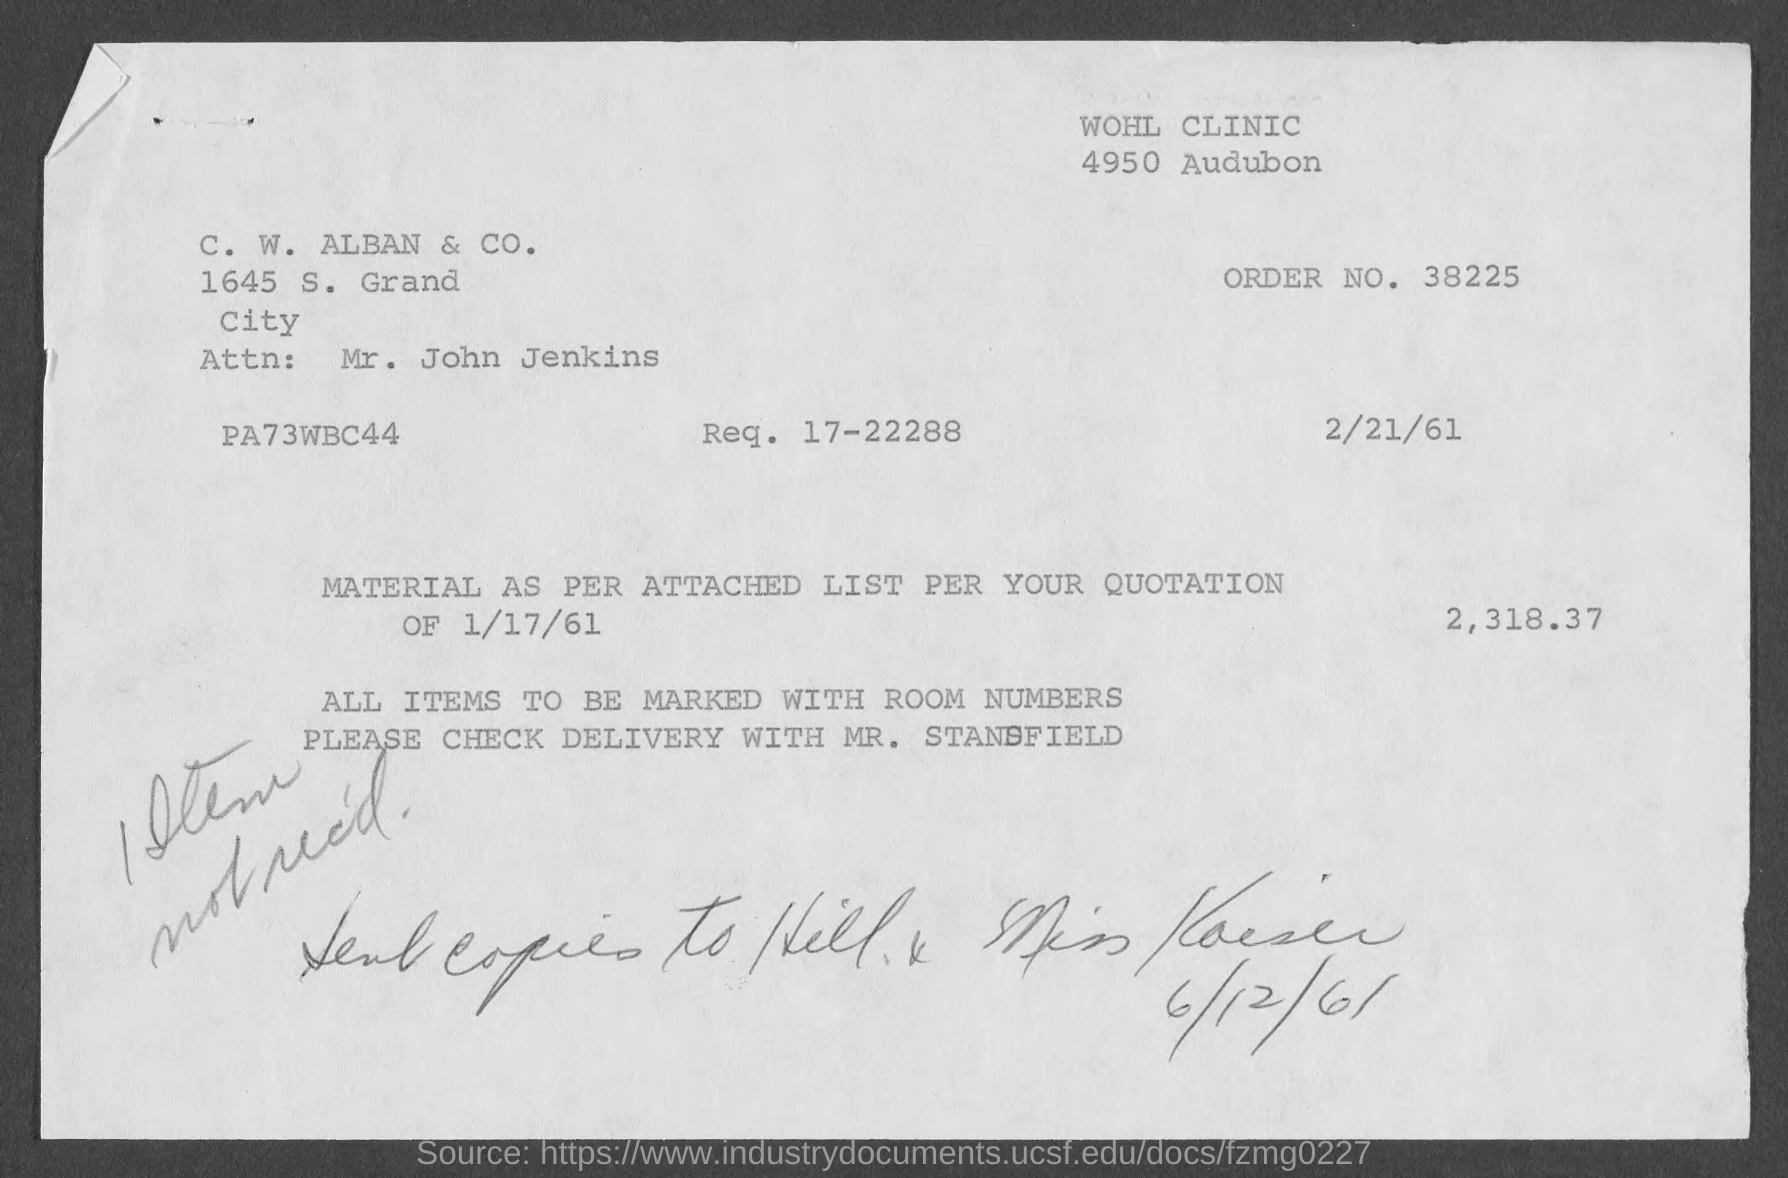Indicate a few pertinent items in this graphic. What is order number 38225...?" is a question asking for information about an order number. The speaker is inquiring about the specific order number in question. The name of the person is Mr. John Jenkins. What is Req. no. 17-22288...?" is a question asking for information about a request number. 